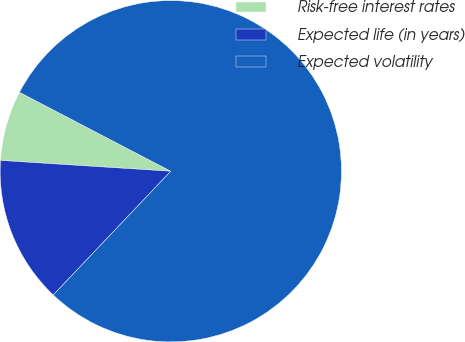Convert chart. <chart><loc_0><loc_0><loc_500><loc_500><pie_chart><fcel>Risk-free interest rates<fcel>Expected life (in years)<fcel>Expected volatility<nl><fcel>6.64%<fcel>13.92%<fcel>79.43%<nl></chart> 